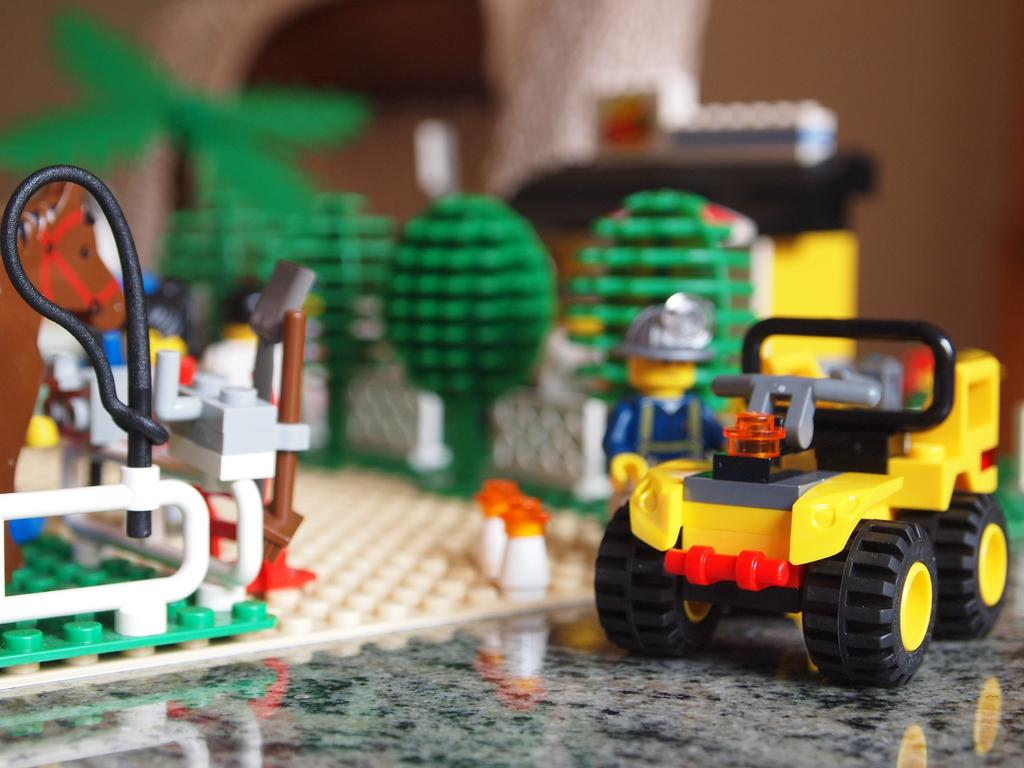What type of toys are present in the image? There are Lego toys in the image. Can you describe the appearance of the Lego toys? The Lego toys are made of small, interlocking plastic bricks that can be assembled to create various structures and figures. What might someone be doing with the Lego toys in the image? Someone might be building or playing with the Lego toys in the image. What type of rabbits can be seen drinking milk in the image? There are no rabbits or milk present in the image; it features Lego toys. 